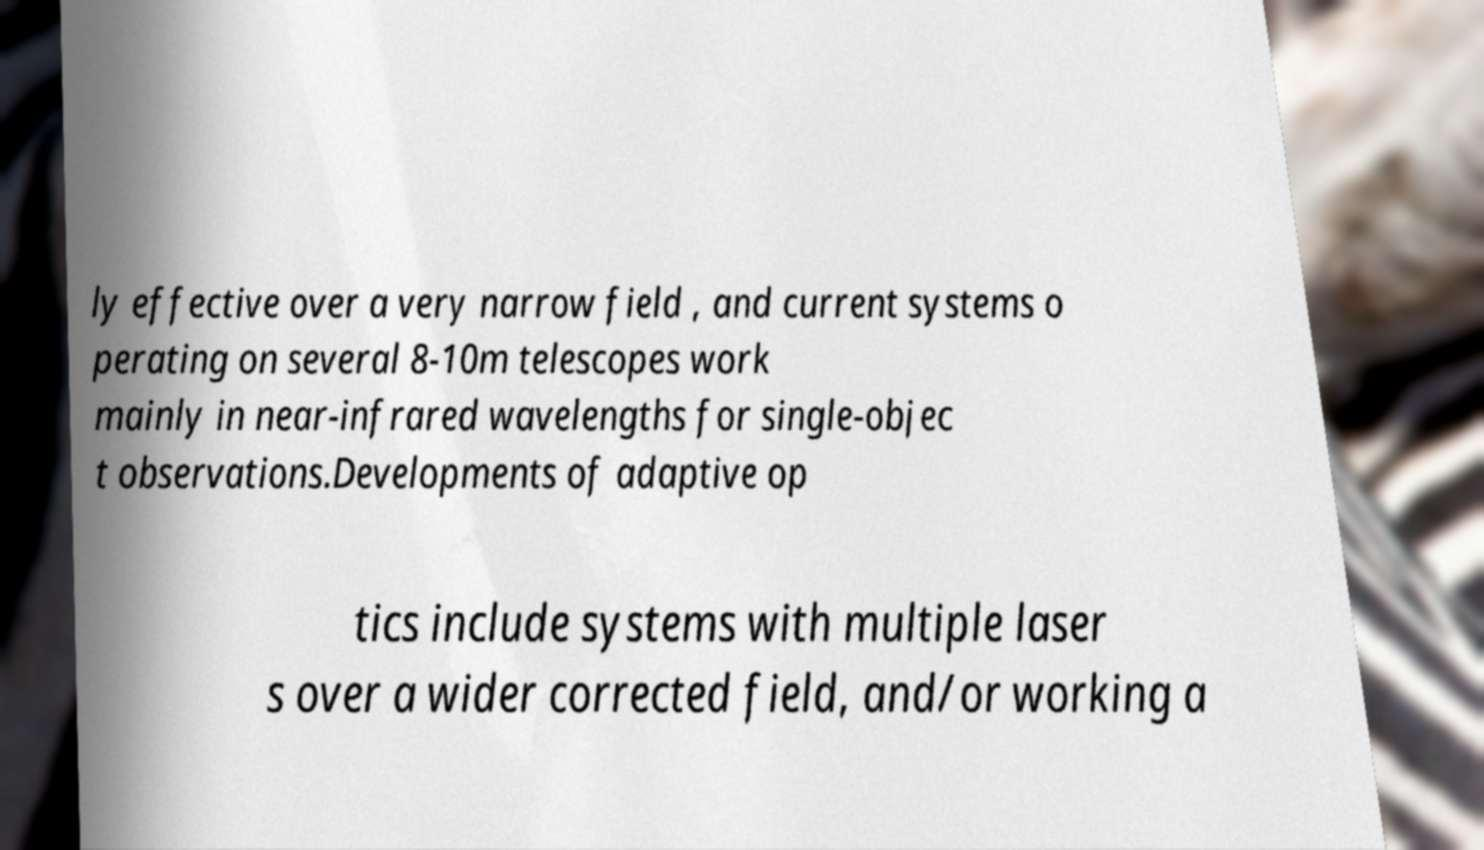Could you extract and type out the text from this image? ly effective over a very narrow field , and current systems o perating on several 8-10m telescopes work mainly in near-infrared wavelengths for single-objec t observations.Developments of adaptive op tics include systems with multiple laser s over a wider corrected field, and/or working a 